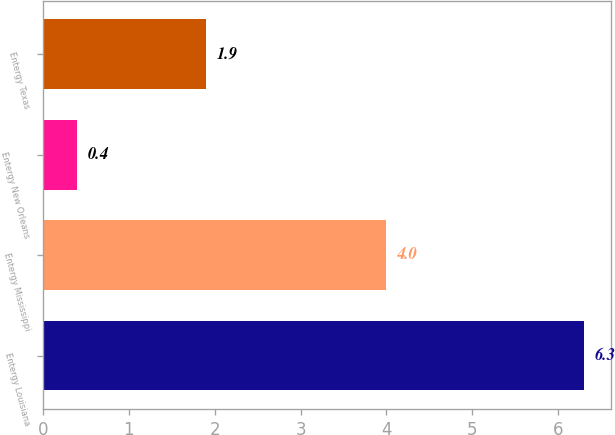Convert chart. <chart><loc_0><loc_0><loc_500><loc_500><bar_chart><fcel>Entergy Louisiana<fcel>Entergy Mississippi<fcel>Entergy New Orleans<fcel>Entergy Texas<nl><fcel>6.3<fcel>4<fcel>0.4<fcel>1.9<nl></chart> 